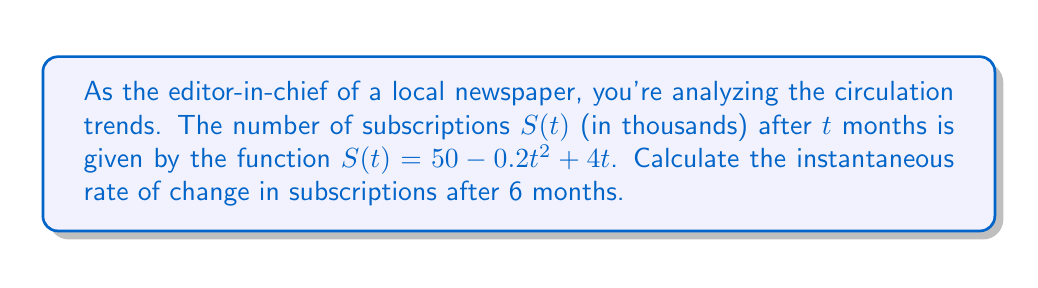Teach me how to tackle this problem. To find the instantaneous rate of change, we need to calculate the derivative of $S(t)$ and evaluate it at $t=6$.

1. Given function: $S(t) = 50 - 0.2t^2 + 4t$

2. Calculate the derivative $S'(t)$:
   $$S'(t) = \frac{d}{dt}(50 - 0.2t^2 + 4t)$$
   $$S'(t) = 0 - 0.4t + 4$$
   $$S'(t) = 4 - 0.4t$$

3. Evaluate $S'(t)$ at $t=6$:
   $$S'(6) = 4 - 0.4(6)$$
   $$S'(6) = 4 - 2.4$$
   $$S'(6) = 1.6$$

The instantaneous rate of change after 6 months is 1.6 thousand subscriptions per month.
Answer: $1.6$ thousand subscriptions/month 